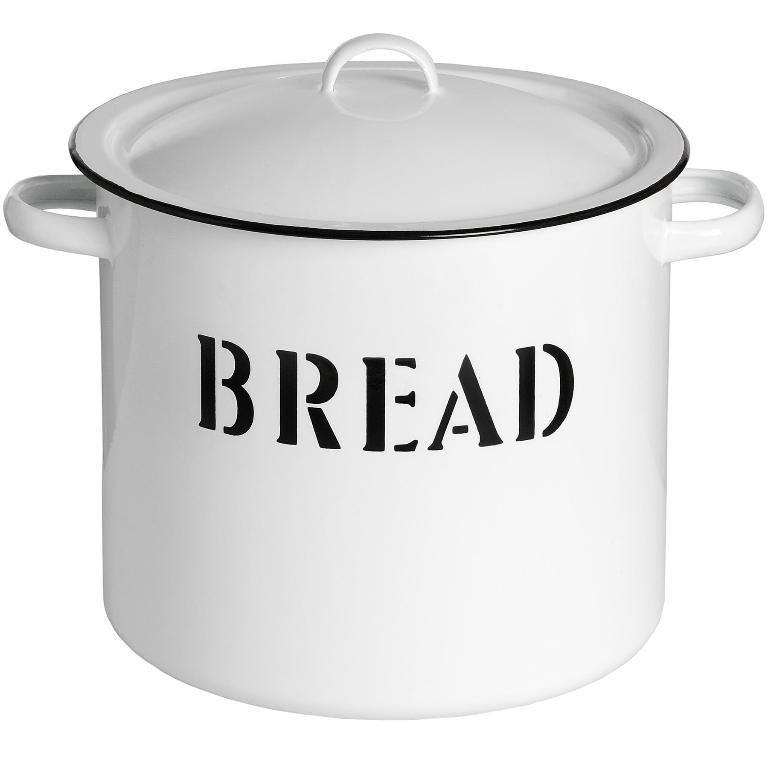<image>
Render a clear and concise summary of the photo. A white pot has the word bread written on it. 